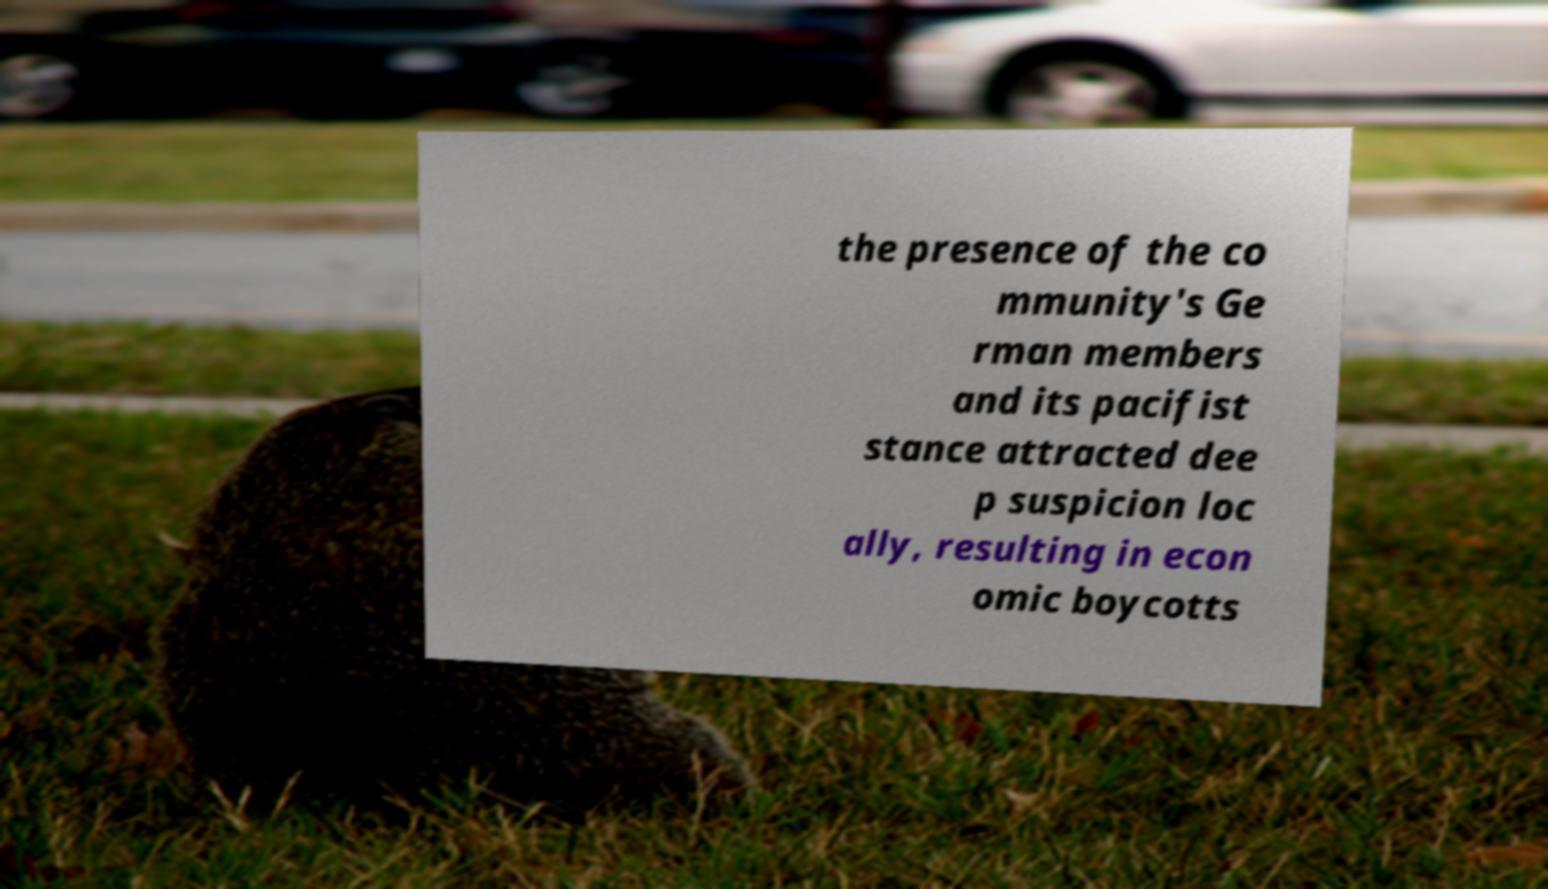Please identify and transcribe the text found in this image. the presence of the co mmunity's Ge rman members and its pacifist stance attracted dee p suspicion loc ally, resulting in econ omic boycotts 